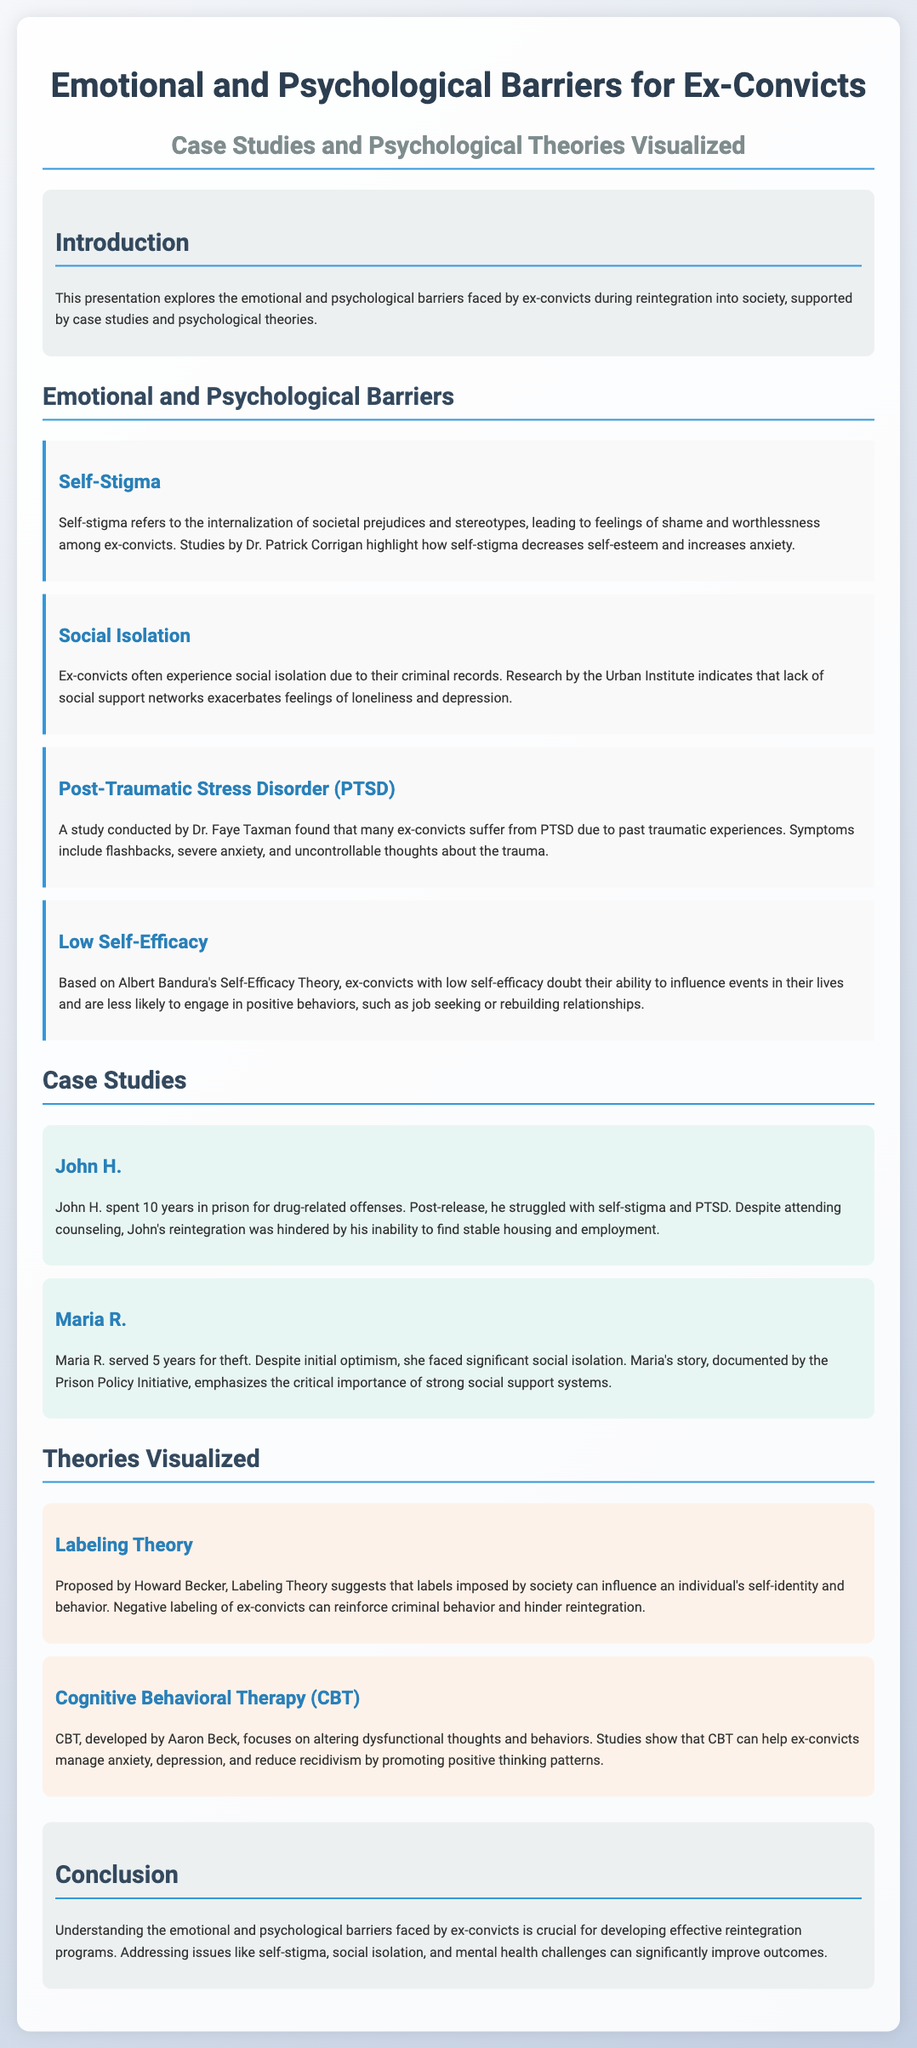What are the emotional and psychological barriers faced by ex-convicts? The document lists several barriers including self-stigma, social isolation, PTSD, and low self-efficacy.
Answer: Self-stigma, social isolation, PTSD, low self-efficacy Who conducted a study on PTSD in ex-convicts? The document attributes a study on PTSD to Dr. Faye Taxman.
Answer: Dr. Faye Taxman What is the primary focus of Cognitive Behavioral Therapy (CBT)? The document states that CBT focuses on altering dysfunctional thoughts and behaviors.
Answer: Altering dysfunctional thoughts and behaviors How many years did John H. spend in prison? The document specifies that John H. spent 10 years in prison for drug-related offenses.
Answer: 10 years What does Labeling Theory suggest about societal labels? The document explains that Labeling Theory suggests labels imposed by society can influence an individual's self-identity and behavior.
Answer: Influence self-identity and behavior What does Albert Bandura's Self-Efficacy Theory relate to ex-convicts? The document indicates that low self-efficacy leads ex-convicts to doubt their ability to influence events in their lives.
Answer: Doubt their ability to influence events What research organization documented Maria R.'s story? According to the document, Maria R.'s story was documented by the Prison Policy Initiative.
Answer: Prison Policy Initiative What is a key outcome of addressing emotional and psychological barriers for ex-convicts? The document concludes that addressing these issues can significantly improve reintegration outcomes.
Answer: Improve reintegration outcomes 